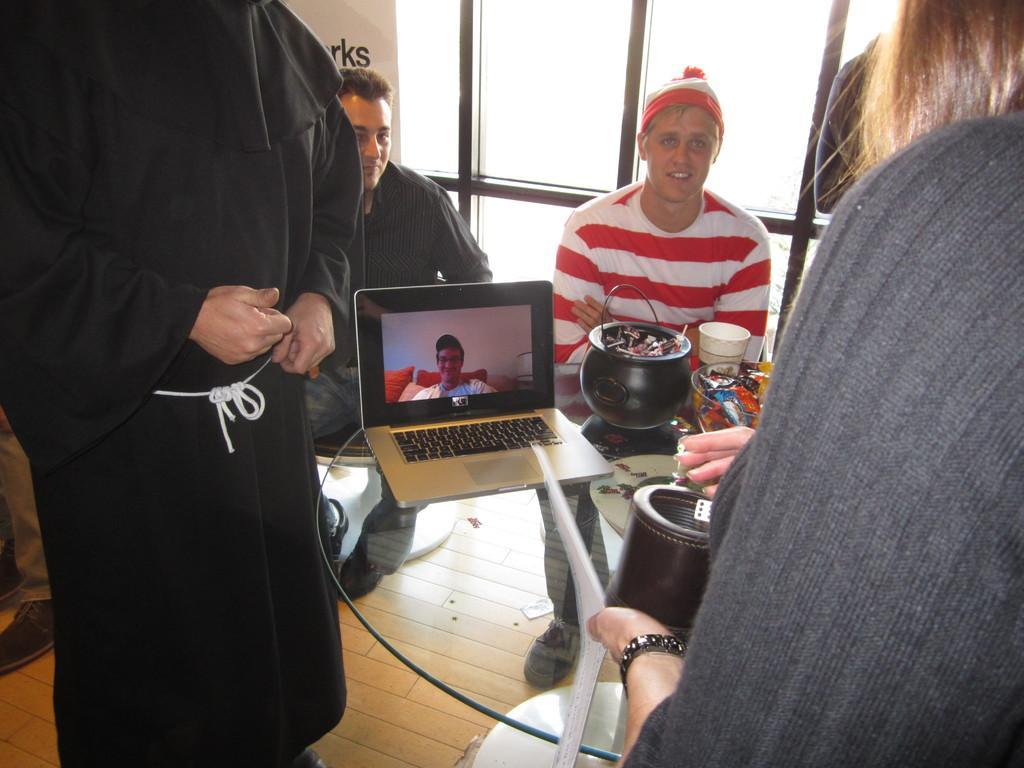In one or two sentences, can you explain what this image depicts? Here we can see few persons and two of them are sitting on the chairs. There is a table. On the table we can see a laptop, bowls, and a cup. In the background we can see glasses. 